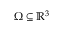<formula> <loc_0><loc_0><loc_500><loc_500>\Omega \subseteq \mathbb { R } ^ { 3 }</formula> 